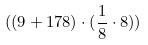Convert formula to latex. <formula><loc_0><loc_0><loc_500><loc_500>( ( 9 + 1 7 8 ) \cdot ( \frac { 1 } { 8 } \cdot 8 ) )</formula> 